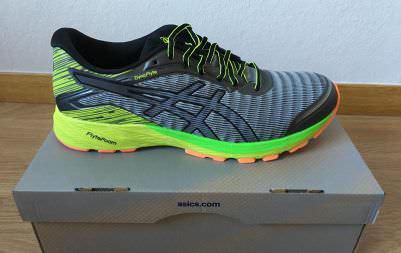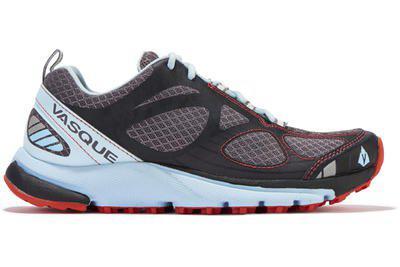The first image is the image on the left, the second image is the image on the right. For the images displayed, is the sentence "Each image contains one right-facing shoe with bright colored treads on the bottom of the sole." factually correct? Answer yes or no. Yes. The first image is the image on the left, the second image is the image on the right. Considering the images on both sides, is "Both shoes are pointing to the right." valid? Answer yes or no. Yes. 